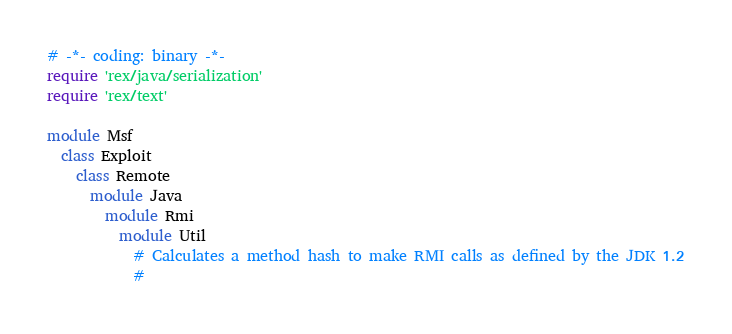<code> <loc_0><loc_0><loc_500><loc_500><_Ruby_># -*- coding: binary -*-
require 'rex/java/serialization'
require 'rex/text'

module Msf
  class Exploit
    class Remote
      module Java
        module Rmi
          module Util
            # Calculates a method hash to make RMI calls as defined by the JDK 1.2
            #</code> 